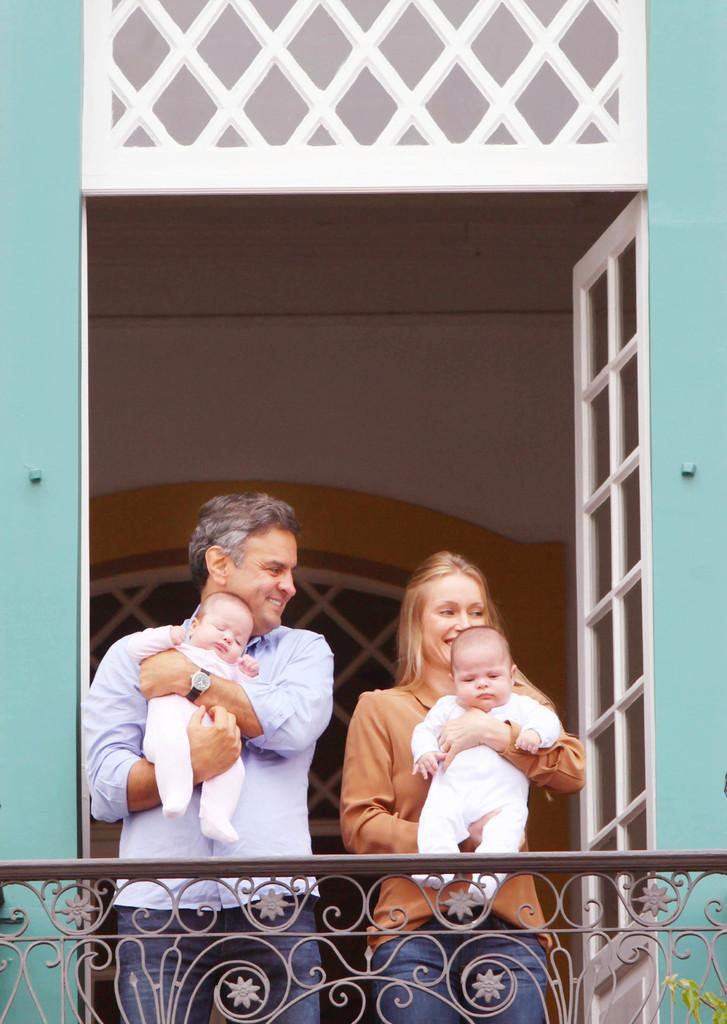How many people are present in the image? There are two people in the image, a woman and a man. What are the woman and man doing in the image? Both the woman and man are carrying babies, and they are smiling. What can be seen at the bottom of the image? There is railing at the bottom of the image. What type of structure is visible in the image? There are walls visible in the image, and there is a door. What object in the image is made of glass? There is a glass object in the image. How many feet are visible in the image? There is no specific mention of feet in the image, so it is not possible to determine how many are visible. 